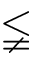Convert formula to latex. <formula><loc_0><loc_0><loc_500><loc_500>\lneqq</formula> 